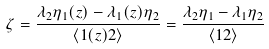Convert formula to latex. <formula><loc_0><loc_0><loc_500><loc_500>\zeta = \frac { \lambda _ { 2 } \eta _ { 1 } ( z ) - \lambda _ { 1 } ( z ) \eta _ { 2 } } { \langle 1 ( z ) 2 \rangle } = \frac { \lambda _ { 2 } \eta _ { 1 } - \lambda _ { 1 } \eta _ { 2 } } { \langle 1 2 \rangle }</formula> 